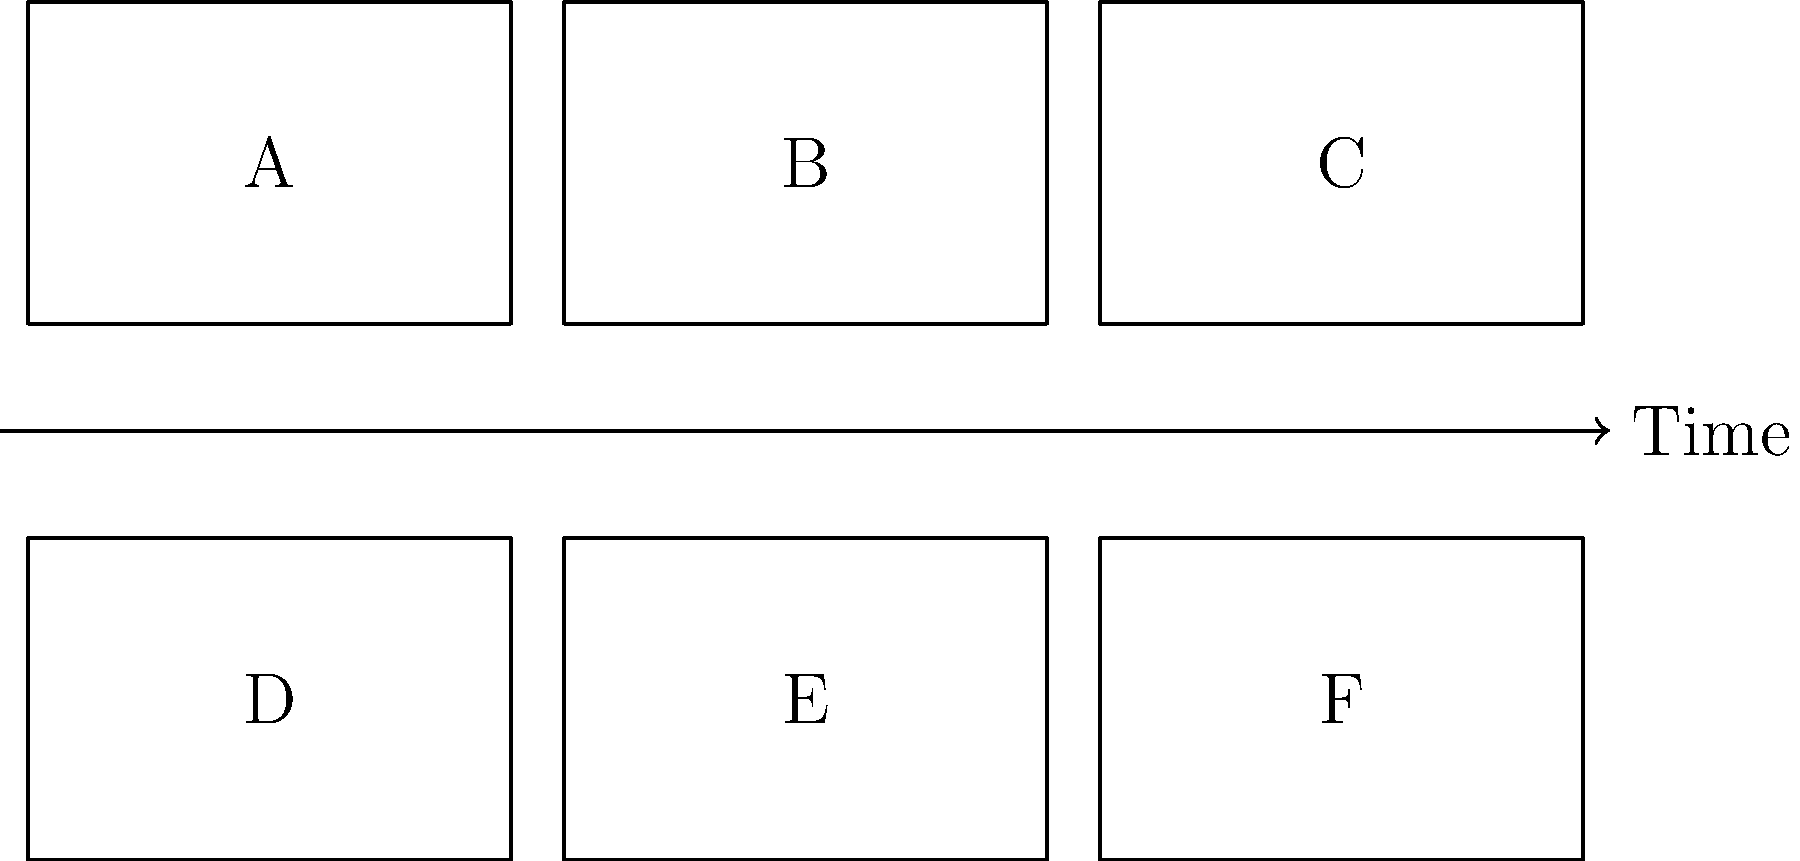As a film journalist, you're analyzing a storyboard sequence for a pivotal scene. Given the six panels labeled A through F, arrange them in the correct chronological order to accurately represent the scene's progression. Which panel should be placed third in the sequence? To determine the correct chronological order of the storyboard panels, we need to analyze the visual storytelling elements and the logical progression of the scene. Let's break it down step-by-step:

1. Examine each panel for visual cues that indicate the beginning, middle, and end of the scene.
2. Look for cause-and-effect relationships between panels.
3. Identify any establishing shots or introductory panels that typically come first.
4. Recognize climactic moments or resolution panels that usually appear towards the end.
5. Consider the flow of action and how it builds throughout the scene.

After careful analysis, the most likely sequence would be:

1. Panel A: Establishing shot or introduction to the scene
2. Panel D: Initial action or character introduction
3. Panel B: Development of the situation or conflict
4. Panel E: Rising action or complication
5. Panel C: Climax of the scene
6. Panel F: Resolution or aftermath

Therefore, the panel that should be placed third in the sequence is Panel B, as it likely represents the development of the situation or conflict introduced in the first two panels.
Answer: B 